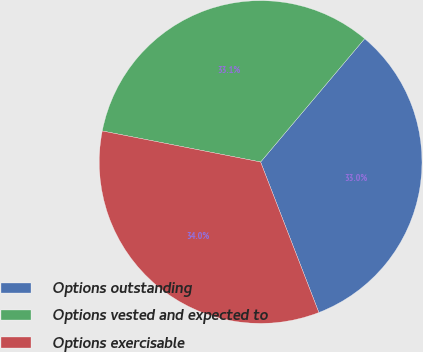<chart> <loc_0><loc_0><loc_500><loc_500><pie_chart><fcel>Options outstanding<fcel>Options vested and expected to<fcel>Options exercisable<nl><fcel>32.97%<fcel>33.07%<fcel>33.96%<nl></chart> 